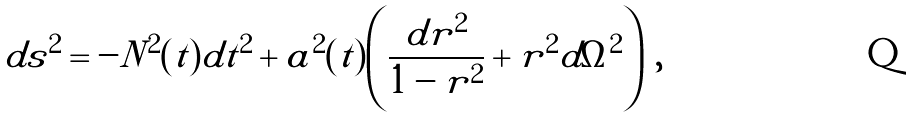Convert formula to latex. <formula><loc_0><loc_0><loc_500><loc_500>d s ^ { 2 } = - N ^ { 2 } ( t ) d t ^ { 2 } + a ^ { 2 } ( t ) \left ( \frac { d r ^ { 2 } } { 1 - r ^ { 2 } } + r ^ { 2 } d \Omega ^ { 2 } \right ) \, ,</formula> 